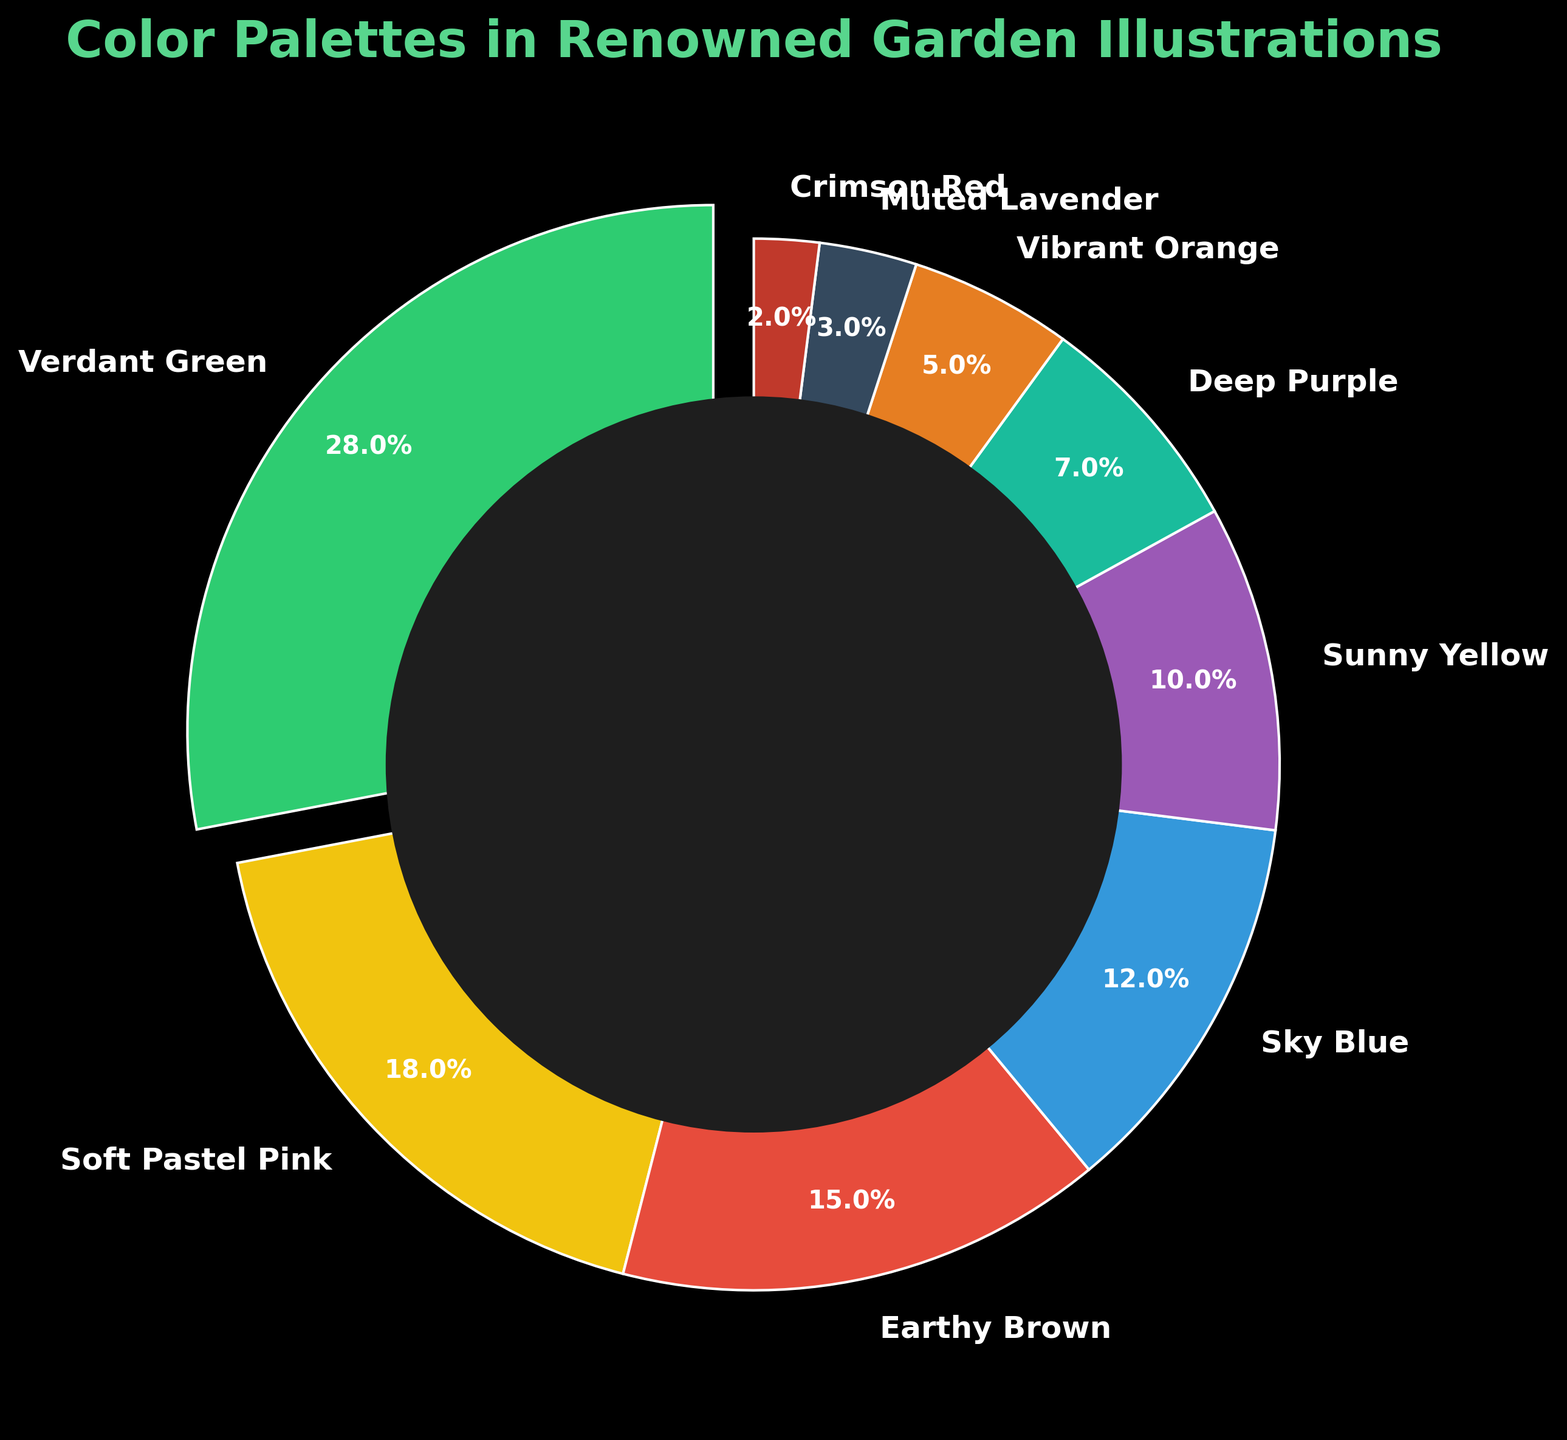What is the most used color palette in renowned garden illustrations? By observing the pie chart, the segment labeled "Verdant Green" occupies the largest portion of the chart. This makes it the most used color palette with 28%.
Answer: Verdant Green Which color palettes combined have a usage percentage of more than 50%? First, identify the percentages for each color. Then sum them to check if they exceed 50%. "Verdant Green" (28%) + "Soft Pastel Pink" (18%) = 46%. Adding "Earthy Brown" (15%) brings it to 61%. Thus, the colors "Verdant Green," "Soft Pastel Pink," and "Earthy Brown" together exceed 50%.
Answer: Verdant Green, Soft Pastel Pink, Earthy Brown What is the least used color palette? By inspecting the size of the pie chart segments, the smallest slice corresponds to "Crimson Red," which has a usage percentage of 2%.
Answer: Crimson Red By how much is the usage percentage of "Sunny Yellow" greater than "Vibrant Orange"? "Sunny Yellow" has a percentage of 10%, and "Vibrant Orange" has 5%. The difference is calculated as 10% - 5%.
Answer: 5% Are "Sky Blue" and "Sunny Yellow" combined used more than "Earthy Brown"? "Sky Blue" has a usage of 12%, and "Sunny Yellow" has 10%. Combined, their usage is 12% + 10% = 22%. "Earthy Brown" has a usage of 15%. Since 22% is greater than 15%, "Sky Blue" and "Sunny Yellow" combined are used more than "Earthy Brown."
Answer: Yes Which color palette occupies the second-largest segment in the pie chart? The second-largest segment after "Verdant Green" (28%) is "Soft Pastel Pink," which occupies 18% of the pie chart.
Answer: Soft Pastel Pink What is the combined percentage of "Muted Lavender" and "Crimson Red"? Add the percentages of "Muted Lavender" (3%) and "Crimson Red" (2%). The total is 3% + 2%.
Answer: 5% Compare the usage of "Deep Purple" with the usage of "Earthy Brown." Which is greater and by how much? "Deep Purple" has a usage of 7%, while "Earthy Brown" has 15%. The difference is calculated as 15% - 7%.
Answer: Earthy Brown, 8% Is "Vibrant Orange" used more frequently than "Muted Lavender"? The pie chart shows "Vibrant Orange" has a usage of 5%, and "Muted Lavender" has 3%. Since 5% is greater than 3%, "Vibrant Orange" is used more frequently.
Answer: Yes What is the total percentage of colors excluding "Verdant Green"? The total percentage of all colors is 100%. Subtract the percentage of "Verdant Green" (28%) from 100% to find the remaining percentage. 100% - 28%.
Answer: 72% 